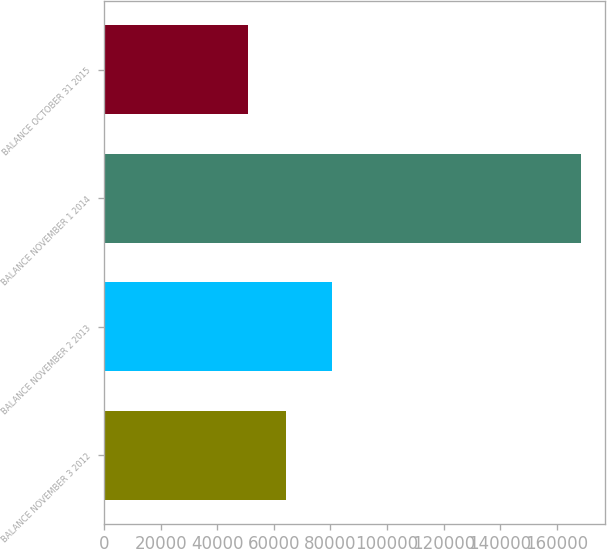Convert chart to OTSL. <chart><loc_0><loc_0><loc_500><loc_500><bar_chart><fcel>BALANCE NOVEMBER 3 2012<fcel>BALANCE NOVEMBER 2 2013<fcel>BALANCE NOVEMBER 1 2014<fcel>BALANCE OCTOBER 31 2015<nl><fcel>64394<fcel>80546<fcel>168526<fcel>50851<nl></chart> 